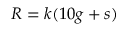Convert formula to latex. <formula><loc_0><loc_0><loc_500><loc_500>R = k ( 1 0 g + s )</formula> 